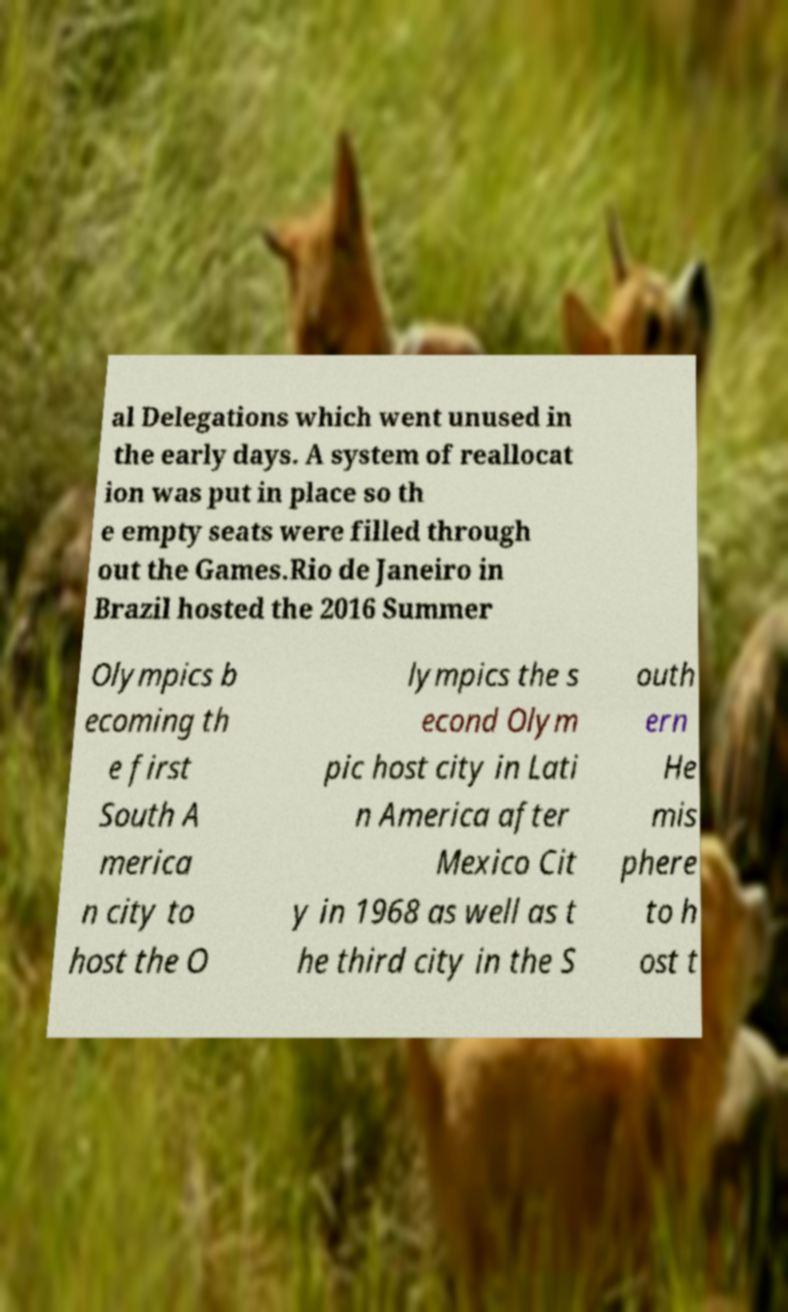What messages or text are displayed in this image? I need them in a readable, typed format. al Delegations which went unused in the early days. A system of reallocat ion was put in place so th e empty seats were filled through out the Games.Rio de Janeiro in Brazil hosted the 2016 Summer Olympics b ecoming th e first South A merica n city to host the O lympics the s econd Olym pic host city in Lati n America after Mexico Cit y in 1968 as well as t he third city in the S outh ern He mis phere to h ost t 